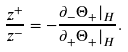Convert formula to latex. <formula><loc_0><loc_0><loc_500><loc_500>\frac { z ^ { + } } { z ^ { - } } = - \frac { \partial _ { - } \Theta _ { + } | _ { H } } { \partial _ { + } \Theta _ { + } | _ { H } } .</formula> 